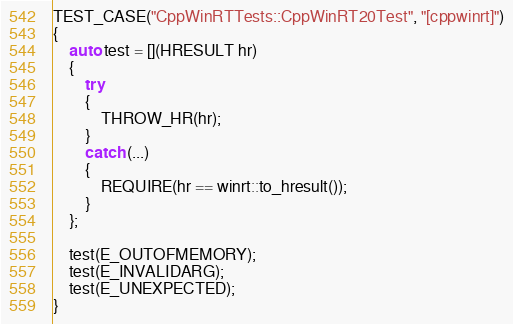Convert code to text. <code><loc_0><loc_0><loc_500><loc_500><_C++_>TEST_CASE("CppWinRTTests::CppWinRT20Test", "[cppwinrt]")
{
    auto test = [](HRESULT hr)
    {
        try
        {
            THROW_HR(hr);
        }
        catch (...)
        {
            REQUIRE(hr == winrt::to_hresult());
        }
    };

    test(E_OUTOFMEMORY);
    test(E_INVALIDARG);
    test(E_UNEXPECTED);
}
</code> 